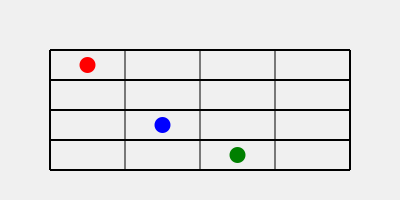If you were to play a chord on the guitar using the finger positions shown in the diagram, which string would produce the highest-pitched note? To determine which string would produce the highest-pitched note, we need to consider two factors:

1. The natural pitch of each string: On a standard guitar, the strings are tuned from lowest to highest pitch in this order: 6th (lowest), 5th, 4th, 3rd, 2nd, 1st (highest).

2. The position of the fingers on the fretboard: Pressing a string against a fret raises the pitch of that string. The further the finger is from the headstock (i.e., the higher the fret number), the higher the pitch becomes.

Looking at the diagram:

1. The red dot is on the 1st fret of the 1st string (highest pitched string).
2. The blue dot is on the 3rd fret of the 3rd string (middle pitch string).
3. The green dot is on the 4th fret of the 5th string (second-lowest pitched string).

Even though the green dot is on the highest fret (4th), it's on a naturally lower-pitched string (5th). The blue dot is on a higher string (3rd) but at a lower fret (3rd).

The red dot, despite being on the lowest fret (1st), is on the naturally highest-pitched string (1st). The 1st string already produces the highest natural pitch, and pressing it at the 1st fret will raise its pitch even further.

Therefore, the 1st string (with the red dot) will produce the highest-pitched note in this chord.
Answer: 1st string (red dot) 